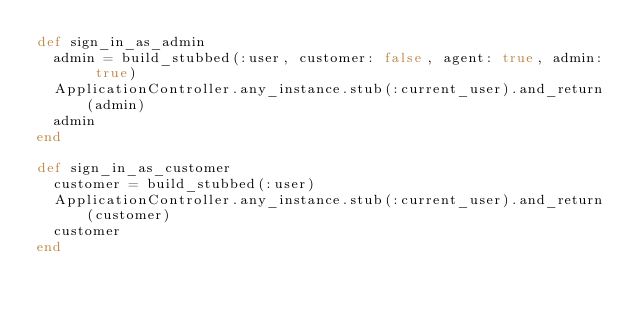<code> <loc_0><loc_0><loc_500><loc_500><_Ruby_>def sign_in_as_admin
  admin = build_stubbed(:user, customer: false, agent: true, admin: true)
  ApplicationController.any_instance.stub(:current_user).and_return(admin)
  admin
end

def sign_in_as_customer
  customer = build_stubbed(:user)
  ApplicationController.any_instance.stub(:current_user).and_return(customer)
  customer
end
</code> 